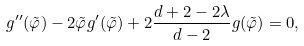<formula> <loc_0><loc_0><loc_500><loc_500>g ^ { \prime \prime } ( \tilde { \varphi } ) - 2 \tilde { \varphi } g ^ { \prime } ( \tilde { \varphi } ) + 2 \frac { d + 2 - 2 \lambda } { d - 2 } g ( \tilde { \varphi } ) = 0 ,</formula> 